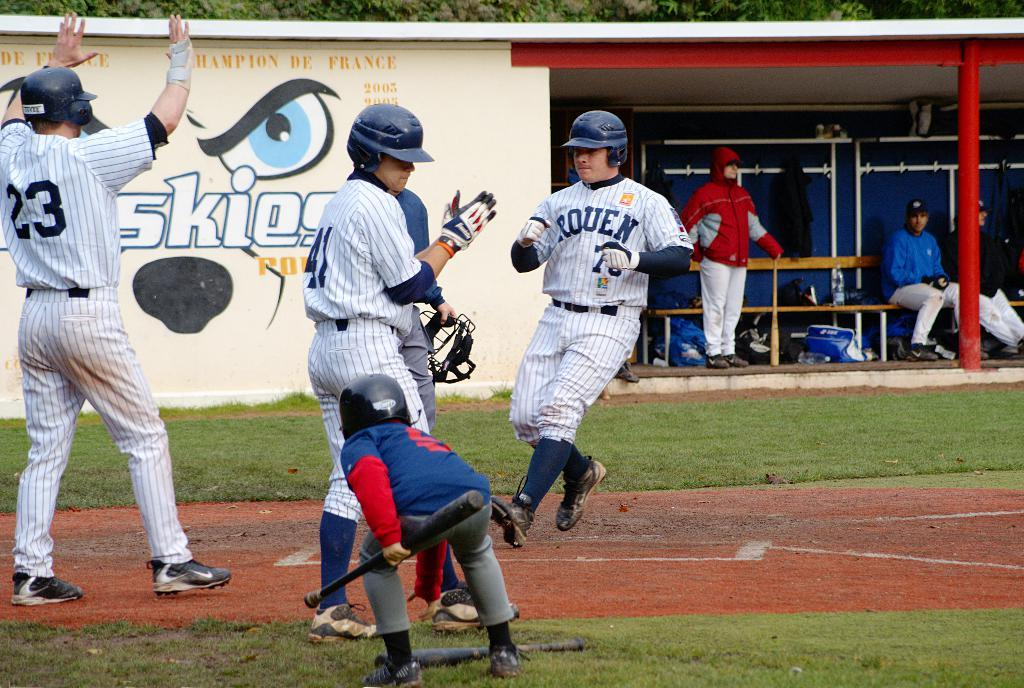<image>
Present a compact description of the photo's key features. The wall behind the players show the Champions of France in past years. 